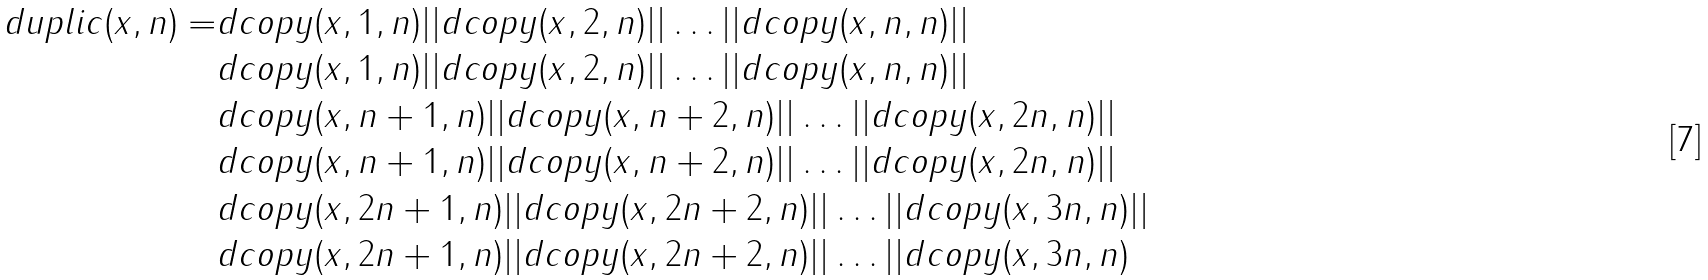Convert formula to latex. <formula><loc_0><loc_0><loc_500><loc_500>d u p l i c ( x , n ) = & d c o p y ( x , 1 , n ) | | d c o p y ( x , 2 , n ) | | \dots | | d c o p y ( x , n , n ) | | \\ & d c o p y ( x , 1 , n ) | | d c o p y ( x , 2 , n ) | | \dots | | d c o p y ( x , n , n ) | | \\ & d c o p y ( x , n + 1 , n ) | | d c o p y ( x , n + 2 , n ) | | \dots | | d c o p y ( x , 2 n , n ) | | \\ & d c o p y ( x , n + 1 , n ) | | d c o p y ( x , n + 2 , n ) | | \dots | | d c o p y ( x , 2 n , n ) | | \\ & d c o p y ( x , 2 n + 1 , n ) | | d c o p y ( x , 2 n + 2 , n ) | | \dots | | d c o p y ( x , 3 n , n ) | | \\ & d c o p y ( x , 2 n + 1 , n ) | | d c o p y ( x , 2 n + 2 , n ) | | \dots | | d c o p y ( x , 3 n , n )</formula> 